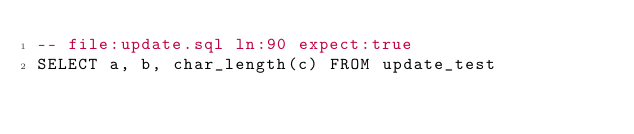Convert code to text. <code><loc_0><loc_0><loc_500><loc_500><_SQL_>-- file:update.sql ln:90 expect:true
SELECT a, b, char_length(c) FROM update_test
</code> 